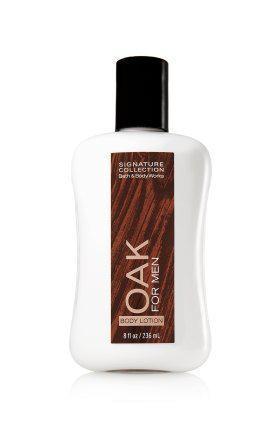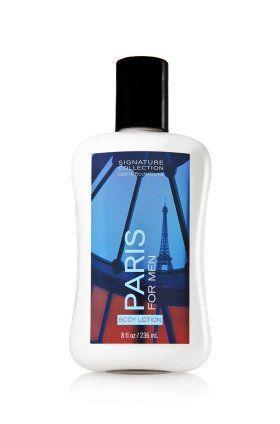The first image is the image on the left, the second image is the image on the right. Assess this claim about the two images: "An image features one product that stands on its black cap.". Correct or not? Answer yes or no. No. The first image is the image on the left, the second image is the image on the right. Evaluate the accuracy of this statement regarding the images: "There are two bottles, both with black caps and white content.". Is it true? Answer yes or no. Yes. 